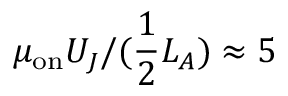Convert formula to latex. <formula><loc_0><loc_0><loc_500><loc_500>\mu _ { o n } U _ { J } / ( \frac { 1 } { 2 } L _ { A } ) \approx 5</formula> 